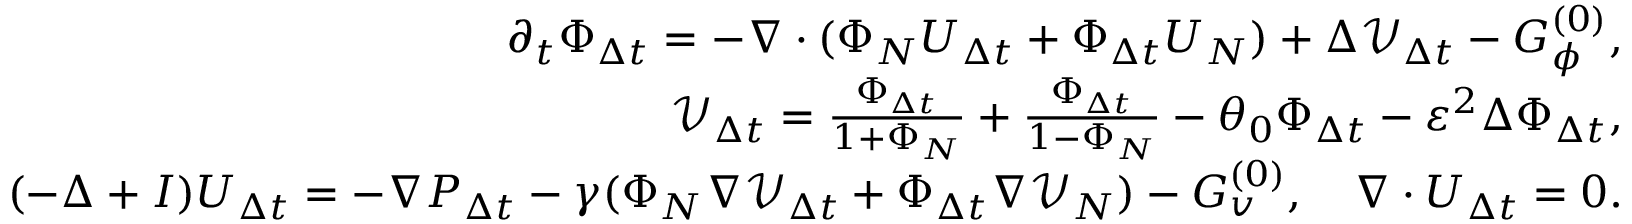Convert formula to latex. <formula><loc_0><loc_0><loc_500><loc_500>\begin{array} { r l r } & { \partial _ { t } \Phi _ { \Delta t } = - \nabla \cdot ( \Phi _ { N } U _ { \Delta t } + \Phi _ { \Delta t } U _ { N } ) + \Delta \mathcal { V } _ { \Delta t } - G _ { \phi } ^ { ( 0 ) } , } \\ & { \mathcal { V } _ { \Delta t } = \frac { \Phi _ { \Delta t } } { 1 + \Phi _ { N } } + \frac { \Phi _ { \Delta t } } { 1 - \Phi _ { N } } - \theta _ { 0 } \Phi _ { \Delta t } - \varepsilon ^ { 2 } \Delta \Phi _ { \Delta t } , } \\ & { ( - \Delta + I ) U _ { \Delta t } = - \nabla P _ { \Delta t } - \gamma ( \Phi _ { N } \nabla \mathcal { V } _ { \Delta t } + \Phi _ { \Delta t } \nabla \mathcal { V } _ { N } ) - G _ { v } ^ { ( 0 ) } , \quad \nabla \cdot U _ { \Delta t } = 0 . } \end{array}</formula> 